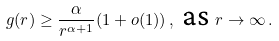Convert formula to latex. <formula><loc_0><loc_0><loc_500><loc_500>g ( r ) \geq \frac { \alpha } { r ^ { \alpha + 1 } } ( 1 + o ( 1 ) ) \, , \text { as } r \to \infty \, .</formula> 